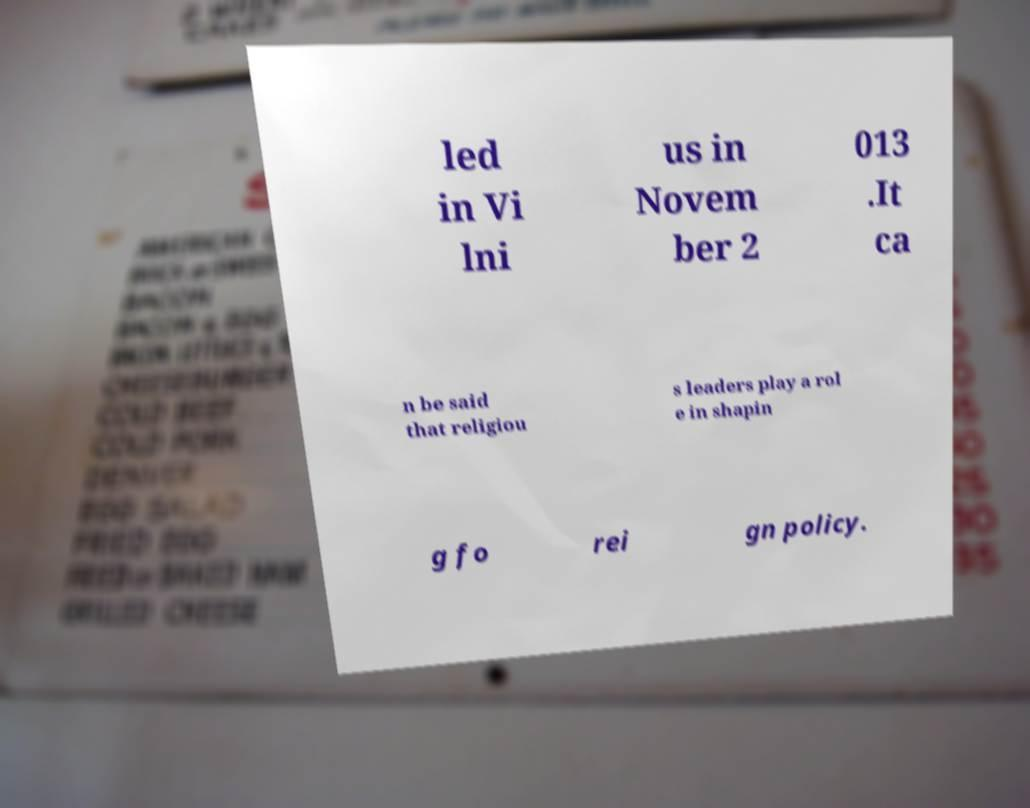Could you extract and type out the text from this image? led in Vi lni us in Novem ber 2 013 .It ca n be said that religiou s leaders play a rol e in shapin g fo rei gn policy. 